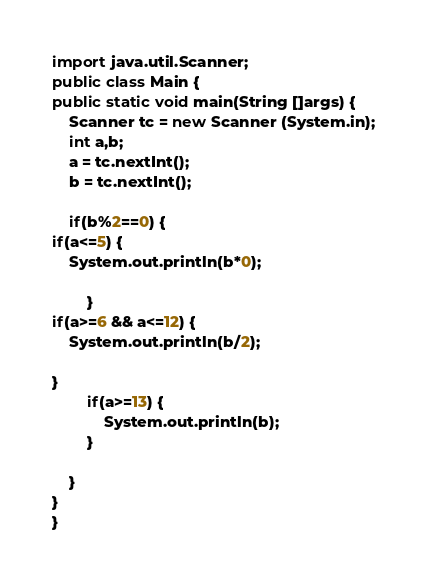Convert code to text. <code><loc_0><loc_0><loc_500><loc_500><_Java_>import java.util.Scanner;
public class Main {
public static void main(String []args) {
	Scanner tc = new Scanner (System.in);
	int a,b;
	a = tc.nextInt();
	b = tc.nextInt();
	
	if(b%2==0) {
if(a<=5) {
	System.out.println(b*0);
			
		}
if(a>=6 && a<=12) {
	System.out.println(b/2);
	
}
		if(a>=13) {
			System.out.println(b);
		}
		
	}
}
}</code> 